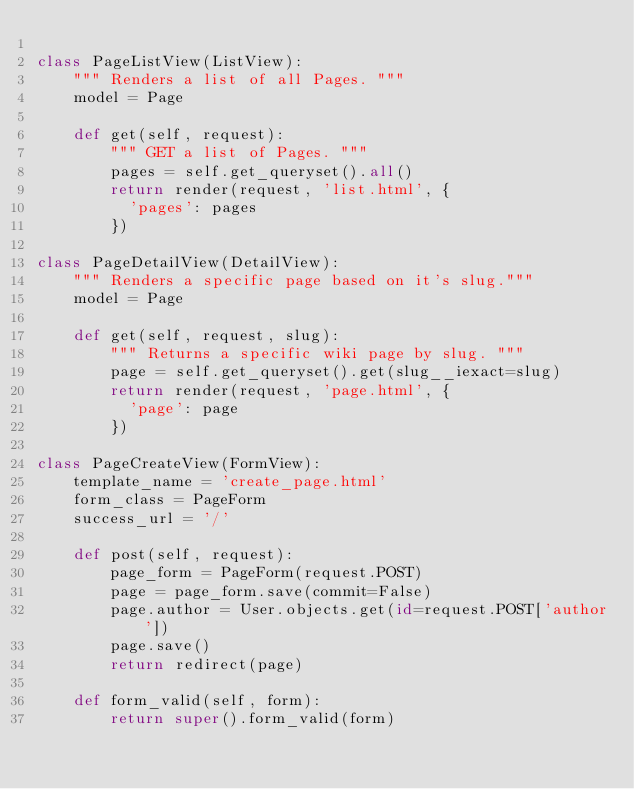<code> <loc_0><loc_0><loc_500><loc_500><_Python_>
class PageListView(ListView):
    """ Renders a list of all Pages. """
    model = Page

    def get(self, request):
        """ GET a list of Pages. """
        pages = self.get_queryset().all()
        return render(request, 'list.html', {
          'pages': pages
        })

class PageDetailView(DetailView):
    """ Renders a specific page based on it's slug."""
    model = Page

    def get(self, request, slug):
        """ Returns a specific wiki page by slug. """
        page = self.get_queryset().get(slug__iexact=slug)
        return render(request, 'page.html', {
          'page': page
        })

class PageCreateView(FormView):
    template_name = 'create_page.html'
    form_class = PageForm
    success_url = '/'

    def post(self, request):
        page_form = PageForm(request.POST)
        page = page_form.save(commit=False)
        page.author = User.objects.get(id=request.POST['author'])
        page.save()
        return redirect(page)

    def form_valid(self, form):
        return super().form_valid(form)</code> 